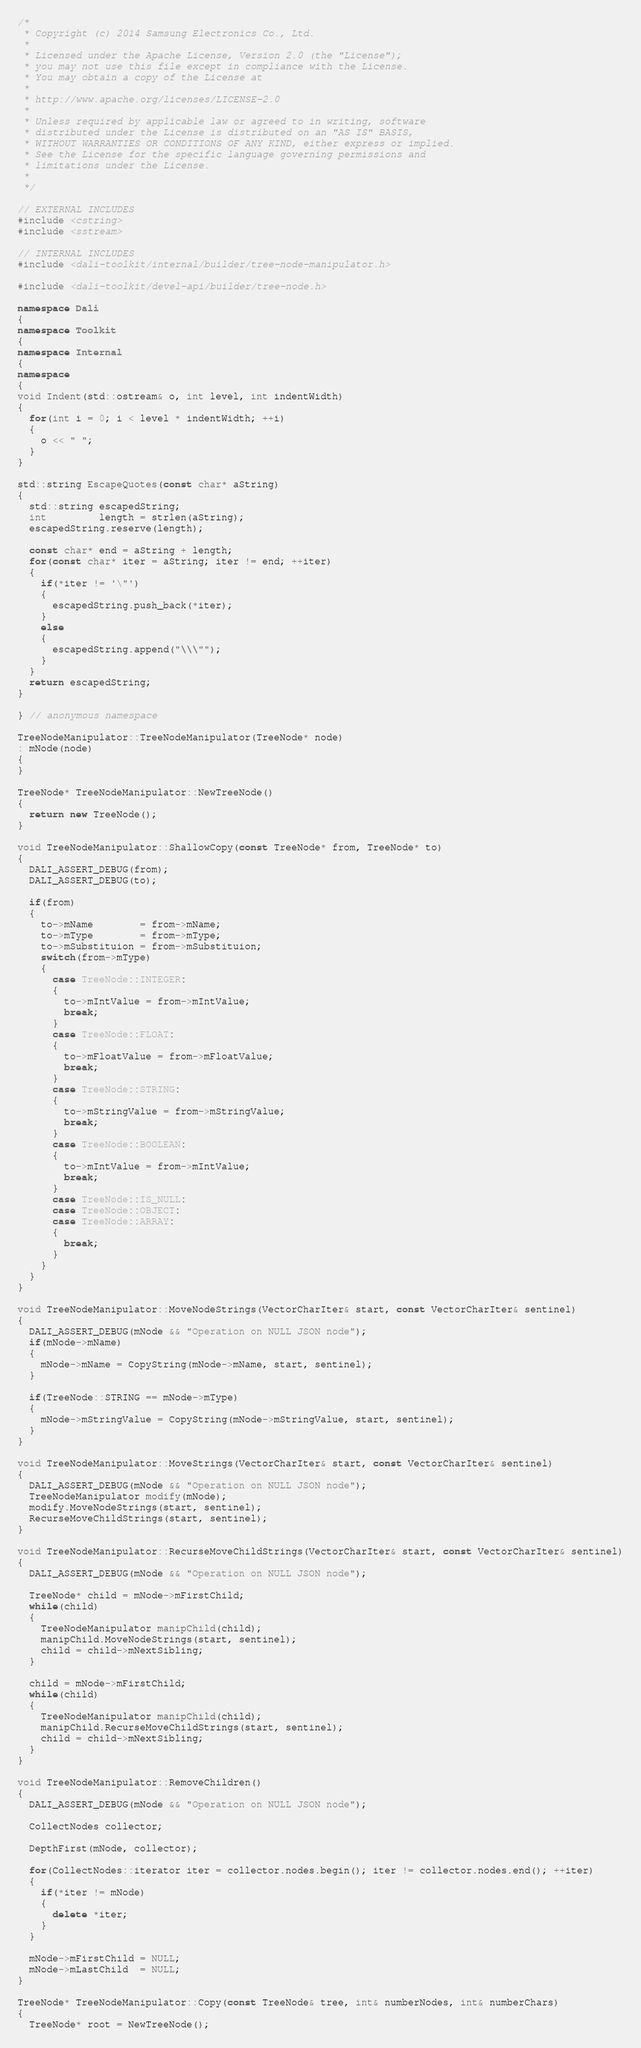Convert code to text. <code><loc_0><loc_0><loc_500><loc_500><_C++_>/*
 * Copyright (c) 2014 Samsung Electronics Co., Ltd.
 *
 * Licensed under the Apache License, Version 2.0 (the "License");
 * you may not use this file except in compliance with the License.
 * You may obtain a copy of the License at
 *
 * http://www.apache.org/licenses/LICENSE-2.0
 *
 * Unless required by applicable law or agreed to in writing, software
 * distributed under the License is distributed on an "AS IS" BASIS,
 * WITHOUT WARRANTIES OR CONDITIONS OF ANY KIND, either express or implied.
 * See the License for the specific language governing permissions and
 * limitations under the License.
 *
 */

// EXTERNAL INCLUDES
#include <cstring>
#include <sstream>

// INTERNAL INCLUDES
#include <dali-toolkit/internal/builder/tree-node-manipulator.h>

#include <dali-toolkit/devel-api/builder/tree-node.h>

namespace Dali
{
namespace Toolkit
{
namespace Internal
{
namespace
{
void Indent(std::ostream& o, int level, int indentWidth)
{
  for(int i = 0; i < level * indentWidth; ++i)
  {
    o << " ";
  }
}

std::string EscapeQuotes(const char* aString)
{
  std::string escapedString;
  int         length = strlen(aString);
  escapedString.reserve(length);

  const char* end = aString + length;
  for(const char* iter = aString; iter != end; ++iter)
  {
    if(*iter != '\"')
    {
      escapedString.push_back(*iter);
    }
    else
    {
      escapedString.append("\\\"");
    }
  }
  return escapedString;
}

} // anonymous namespace

TreeNodeManipulator::TreeNodeManipulator(TreeNode* node)
: mNode(node)
{
}

TreeNode* TreeNodeManipulator::NewTreeNode()
{
  return new TreeNode();
}

void TreeNodeManipulator::ShallowCopy(const TreeNode* from, TreeNode* to)
{
  DALI_ASSERT_DEBUG(from);
  DALI_ASSERT_DEBUG(to);

  if(from)
  {
    to->mName        = from->mName;
    to->mType        = from->mType;
    to->mSubstituion = from->mSubstituion;
    switch(from->mType)
    {
      case TreeNode::INTEGER:
      {
        to->mIntValue = from->mIntValue;
        break;
      }
      case TreeNode::FLOAT:
      {
        to->mFloatValue = from->mFloatValue;
        break;
      }
      case TreeNode::STRING:
      {
        to->mStringValue = from->mStringValue;
        break;
      }
      case TreeNode::BOOLEAN:
      {
        to->mIntValue = from->mIntValue;
        break;
      }
      case TreeNode::IS_NULL:
      case TreeNode::OBJECT:
      case TreeNode::ARRAY:
      {
        break;
      }
    }
  }
}

void TreeNodeManipulator::MoveNodeStrings(VectorCharIter& start, const VectorCharIter& sentinel)
{
  DALI_ASSERT_DEBUG(mNode && "Operation on NULL JSON node");
  if(mNode->mName)
  {
    mNode->mName = CopyString(mNode->mName, start, sentinel);
  }

  if(TreeNode::STRING == mNode->mType)
  {
    mNode->mStringValue = CopyString(mNode->mStringValue, start, sentinel);
  }
}

void TreeNodeManipulator::MoveStrings(VectorCharIter& start, const VectorCharIter& sentinel)
{
  DALI_ASSERT_DEBUG(mNode && "Operation on NULL JSON node");
  TreeNodeManipulator modify(mNode);
  modify.MoveNodeStrings(start, sentinel);
  RecurseMoveChildStrings(start, sentinel);
}

void TreeNodeManipulator::RecurseMoveChildStrings(VectorCharIter& start, const VectorCharIter& sentinel)
{
  DALI_ASSERT_DEBUG(mNode && "Operation on NULL JSON node");

  TreeNode* child = mNode->mFirstChild;
  while(child)
  {
    TreeNodeManipulator manipChild(child);
    manipChild.MoveNodeStrings(start, sentinel);
    child = child->mNextSibling;
  }

  child = mNode->mFirstChild;
  while(child)
  {
    TreeNodeManipulator manipChild(child);
    manipChild.RecurseMoveChildStrings(start, sentinel);
    child = child->mNextSibling;
  }
}

void TreeNodeManipulator::RemoveChildren()
{
  DALI_ASSERT_DEBUG(mNode && "Operation on NULL JSON node");

  CollectNodes collector;

  DepthFirst(mNode, collector);

  for(CollectNodes::iterator iter = collector.nodes.begin(); iter != collector.nodes.end(); ++iter)
  {
    if(*iter != mNode)
    {
      delete *iter;
    }
  }

  mNode->mFirstChild = NULL;
  mNode->mLastChild  = NULL;
}

TreeNode* TreeNodeManipulator::Copy(const TreeNode& tree, int& numberNodes, int& numberChars)
{
  TreeNode* root = NewTreeNode();
</code> 